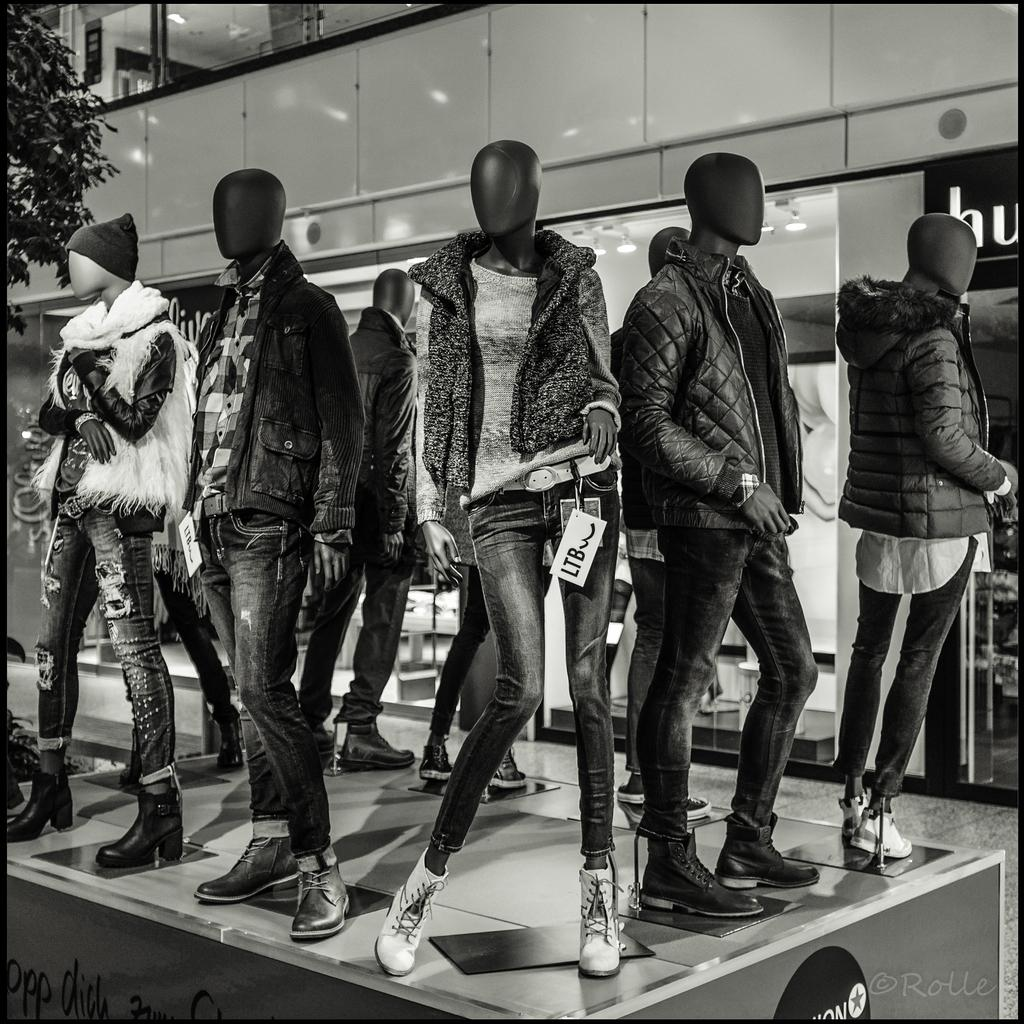What type of objects are in the image? There are mannequins in the image. What are the mannequins wearing? The mannequins are wearing different types of jackets. Can you describe any natural elements in the image? There is a part of a plant visible in the image. What is in the background of the image suggests a man-made structure? There is a building wall with glass in the background of the image. What type of car can be seen parked next to the mannequins in the image? There is no car present in the image; it only features mannequins, jackets, a plant, and a building wall with glass. What authority figure is depicted among the mannequins in the image? There is no authority figure present in the image; it only features mannequins and jackets. 